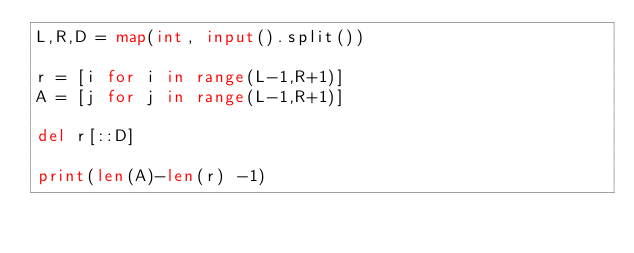<code> <loc_0><loc_0><loc_500><loc_500><_Python_>L,R,D = map(int, input().split())

r = [i for i in range(L-1,R+1)]
A = [j for j in range(L-1,R+1)]

del r[::D]

print(len(A)-len(r) -1)</code> 